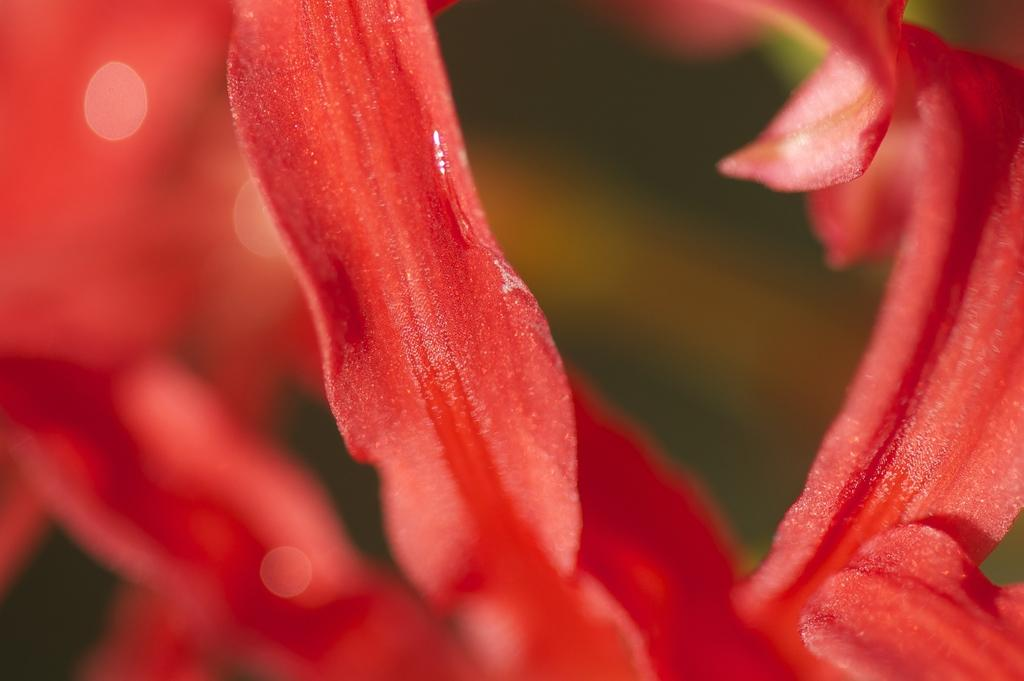What is the main subject of the image? There is a flower in the image. Can you describe the background of the image? The background of the image is blurred. How many plants are folded in the image? There are no plants present in the image, let alone any that are folded. 